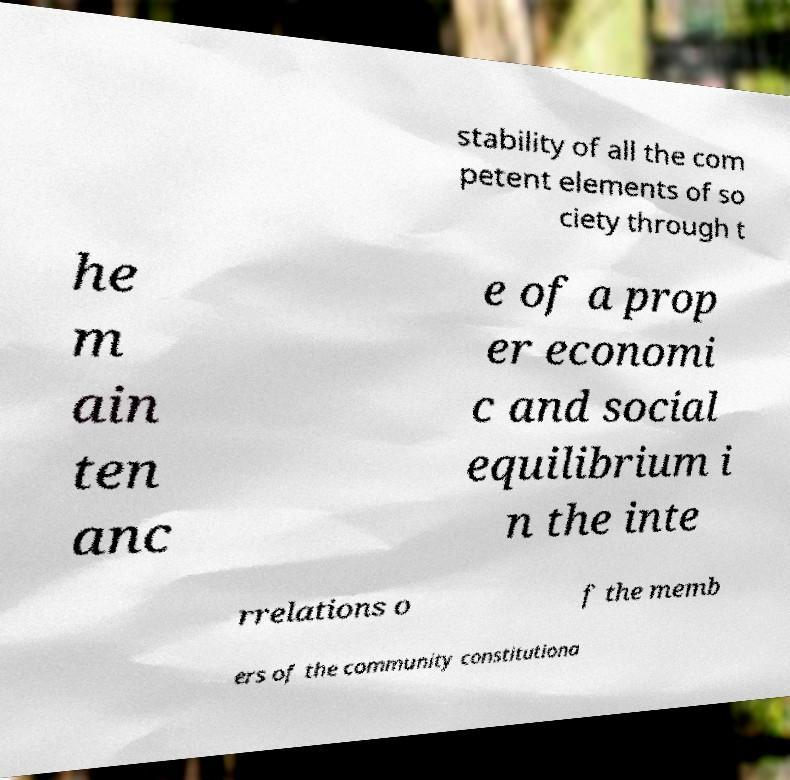I need the written content from this picture converted into text. Can you do that? stability of all the com petent elements of so ciety through t he m ain ten anc e of a prop er economi c and social equilibrium i n the inte rrelations o f the memb ers of the community constitutiona 